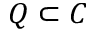<formula> <loc_0><loc_0><loc_500><loc_500>Q \subset C</formula> 